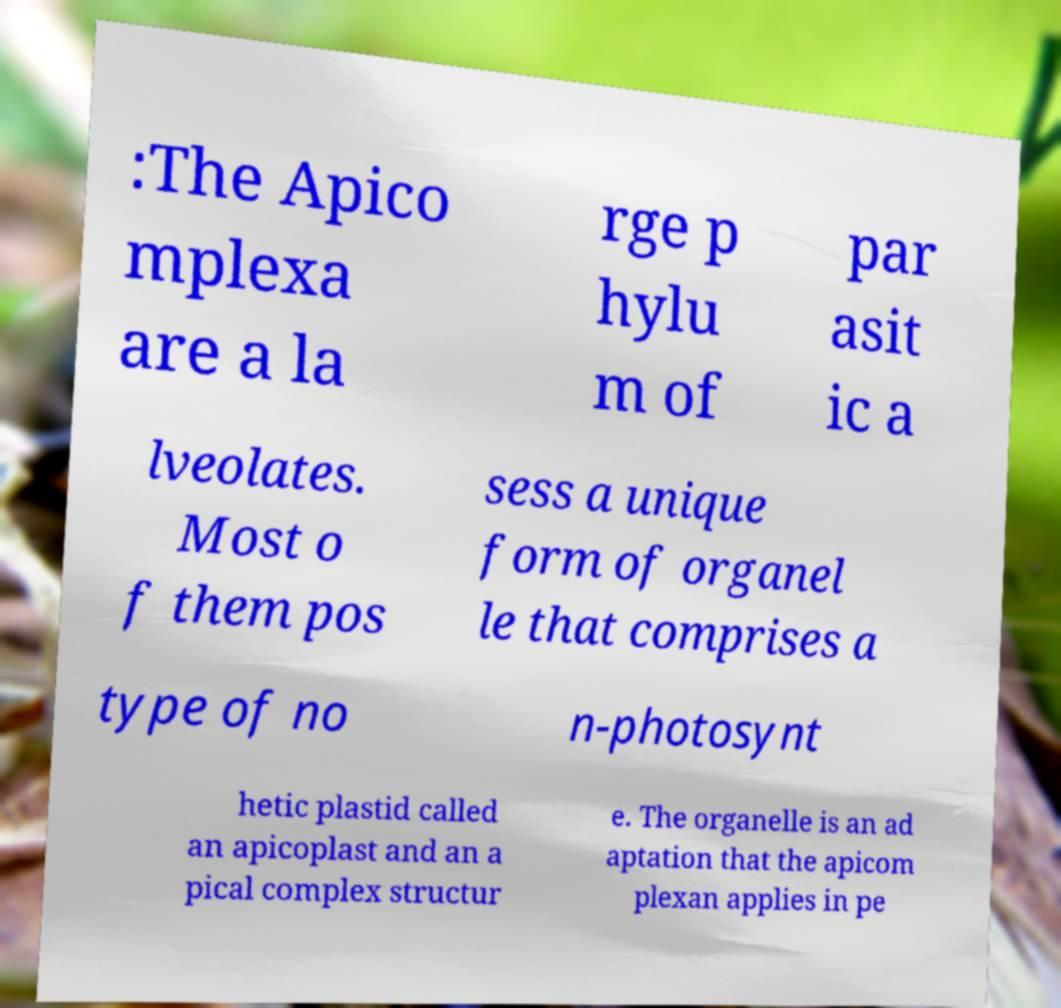Please identify and transcribe the text found in this image. :The Apico mplexa are a la rge p hylu m of par asit ic a lveolates. Most o f them pos sess a unique form of organel le that comprises a type of no n-photosynt hetic plastid called an apicoplast and an a pical complex structur e. The organelle is an ad aptation that the apicom plexan applies in pe 